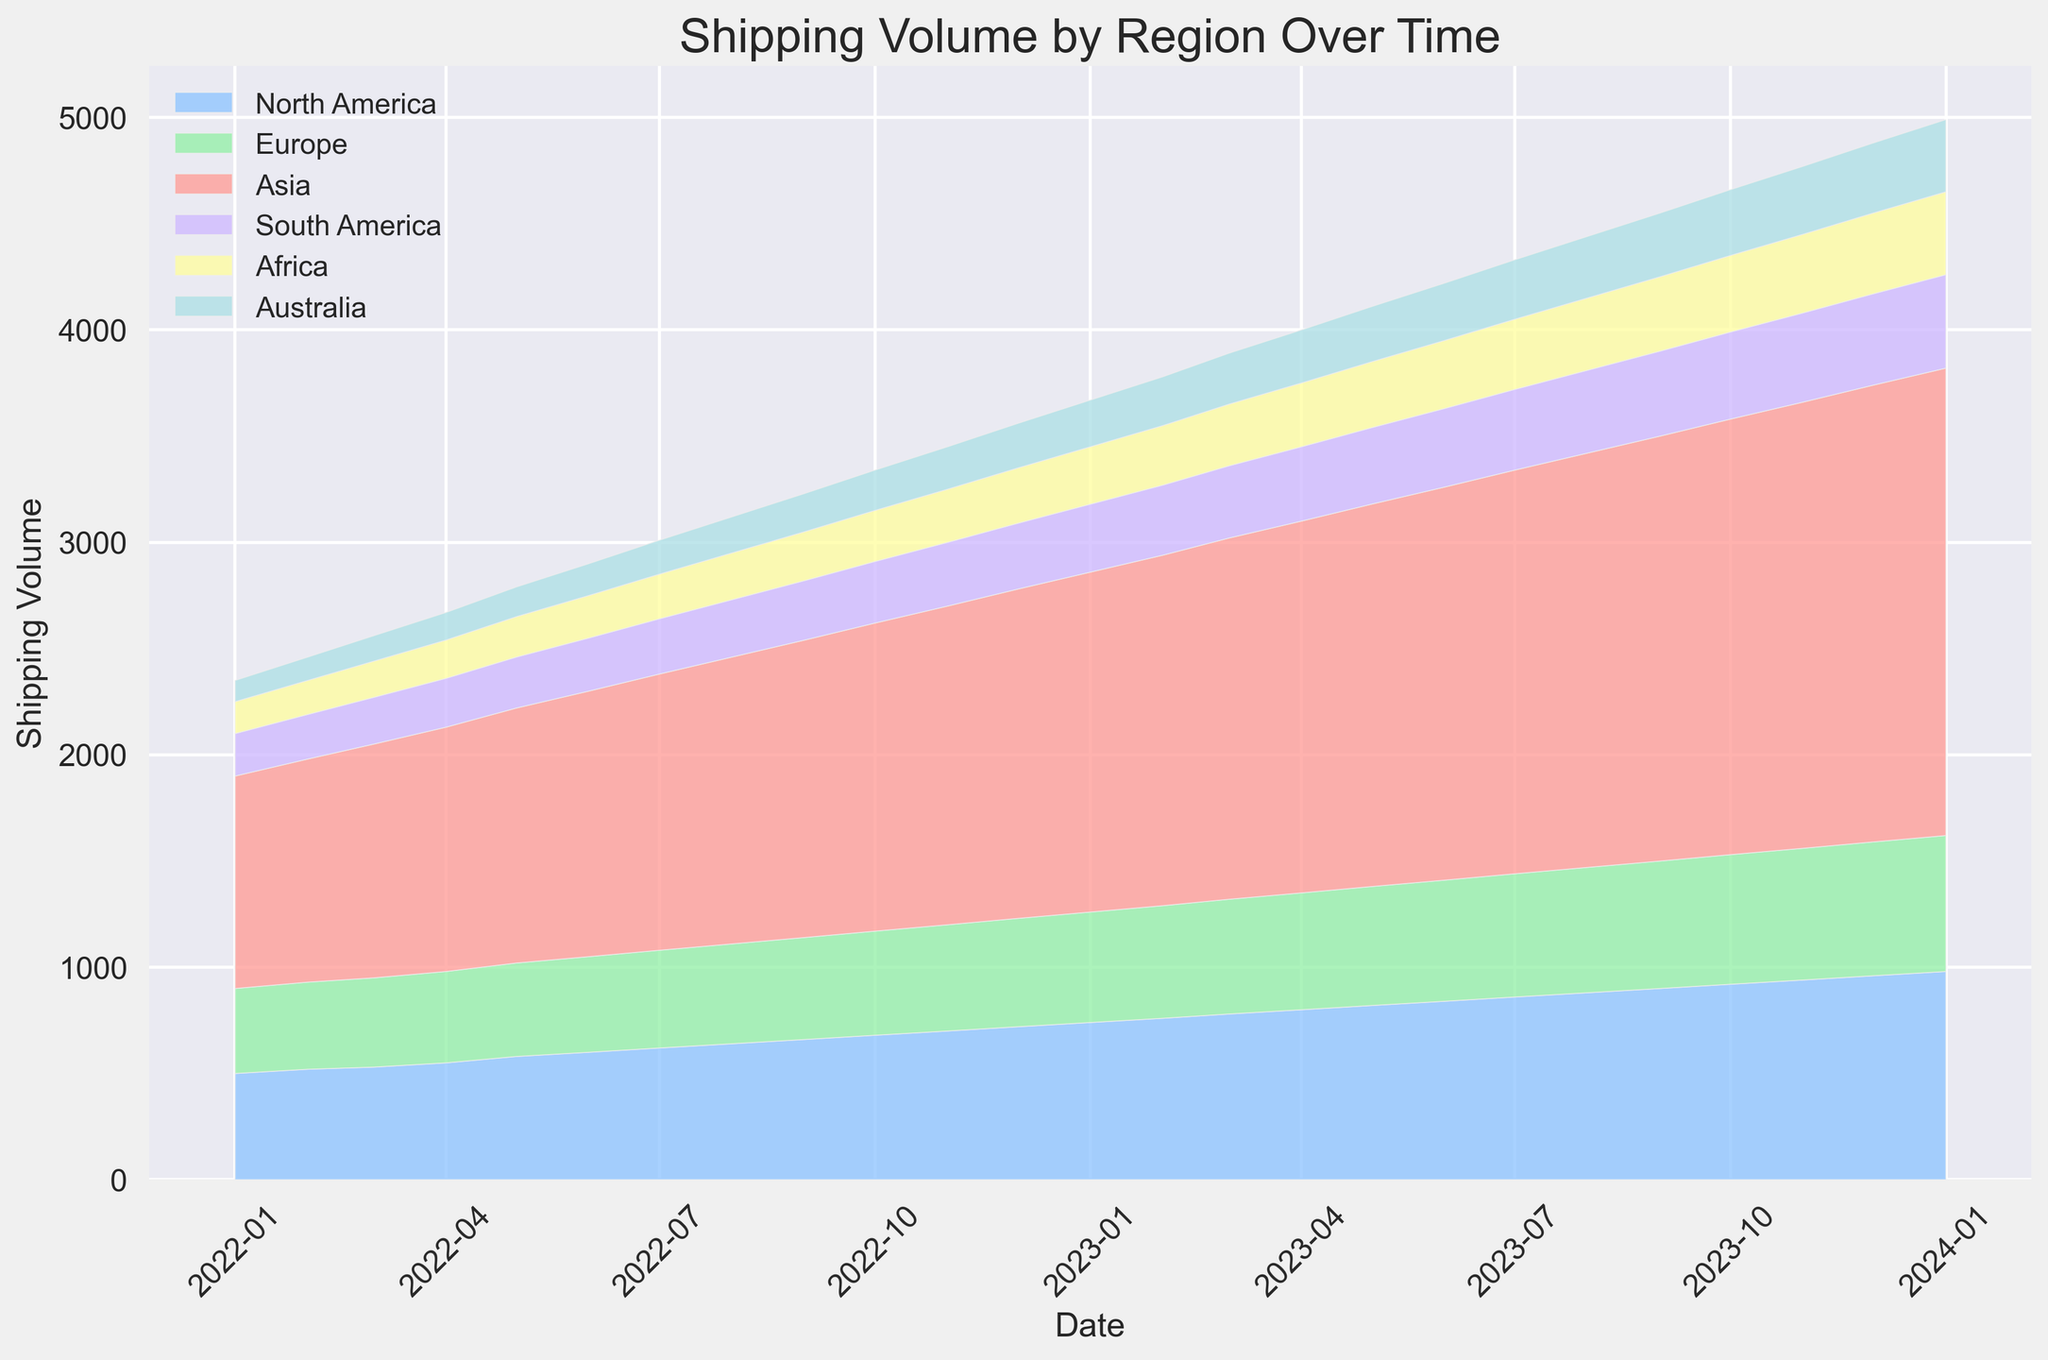Which region has the highest shipping volume at the end of the time period? At the end of the time period (January 2024), the region with the highest shipping volume is the one represented by the largest area at that point. The chart shows that Asia has the largest area compared to other regions.
Answer: Asia Which region shows the smallest increase in shipping volume over the entire period? To determine this, compare the difference in shipping volume from the start to the end of the period for each region. Africa has the smallest increase from approximately 150 to 390, which is a difference of 240.
Answer: Africa What is the difference in shipping volume between North America and Europe in January 2024? Find the shipping volumes for North America and Europe in January 2024 from the chart. Subtract Europe’s volume (640) from North America’s volume (980): 980 - 640 = 340.
Answer: 340 In which month did both Australia and South America have the same shipping volume? Check the chart for the point where the areas representing Australia and South America intersect. This happens around September 2022 when both have a shipping volume of approximately 180.
Answer: September 2022 Which region had the most consistent increase in shipping volume over the time period? A consistent increase would be indicated by a steady slope in the area chart. North America shows a steady, consistent increase without any noticeable fluctuations or rapid changes.
Answer: North America Between July 2022 and July 2023, which region showed the largest increase in shipping volume? Compare the difference in shipping volume from July 2022 to July 2023 for each region. For Asia, it increased from 1300 to 1900, a difference of 600, which is the largest among all regions during that period.
Answer: Asia During which month did Europe first exceed 500 in shipping volume? Identify the month at which the area for Europe first crosses above the 500 threshold in height. This occurs in November 2022.
Answer: November 2022 By how much did South America's shipping volume increase from January 2022 to January 2023? Find South America's shipping volume in January 2022 (200) and January 2023 (320), then subtract the earlier volume from the later one: 320 - 200 = 120.
Answer: 120 